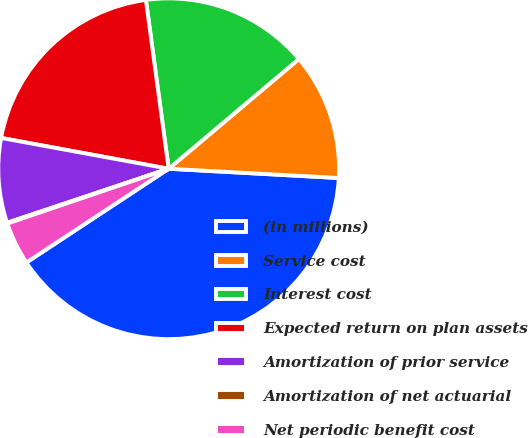<chart> <loc_0><loc_0><loc_500><loc_500><pie_chart><fcel>(in millions)<fcel>Service cost<fcel>Interest cost<fcel>Expected return on plan assets<fcel>Amortization of prior service<fcel>Amortization of net actuarial<fcel>Net periodic benefit cost<nl><fcel>39.86%<fcel>12.01%<fcel>15.99%<fcel>19.97%<fcel>8.03%<fcel>0.08%<fcel>4.06%<nl></chart> 